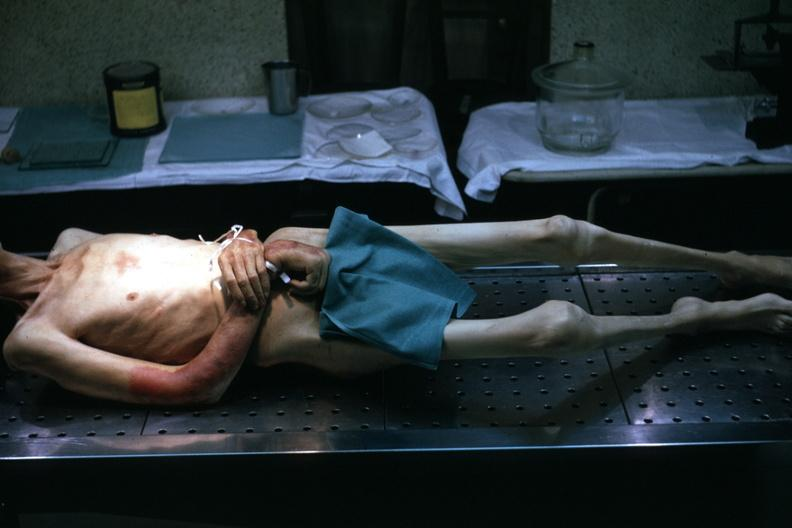s muscle atrophy present?
Answer the question using a single word or phrase. No 